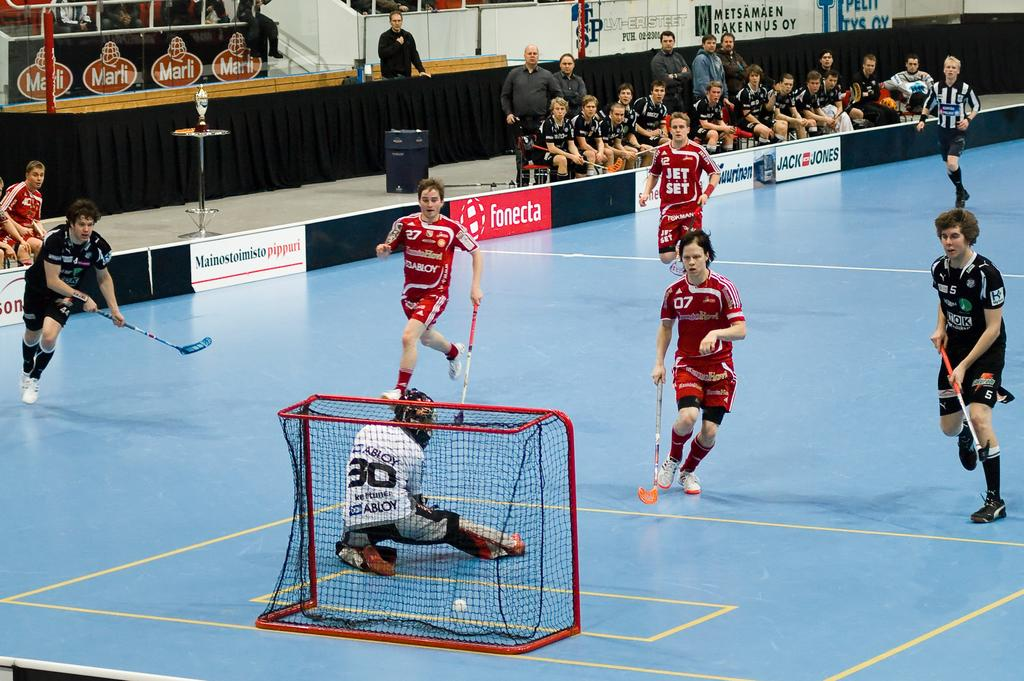<image>
Relay a brief, clear account of the picture shown. People playing a sport on a stadium that is sponsored by "fonecta". 